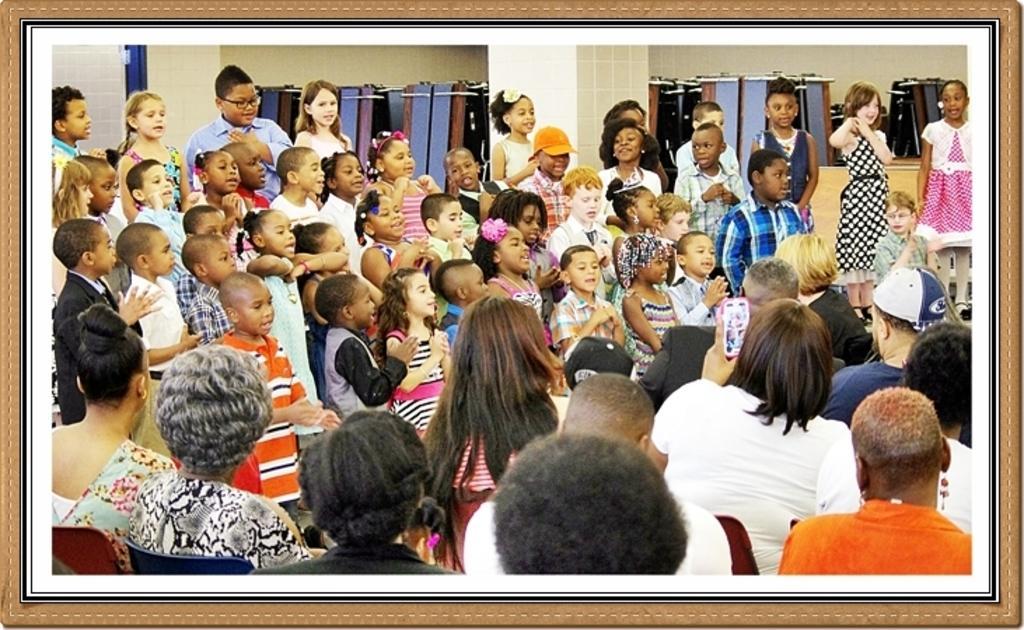How would you summarize this image in a sentence or two? In this picture I can see a group of people are sitting, at the bottom. In the middle I can see a group of children. 